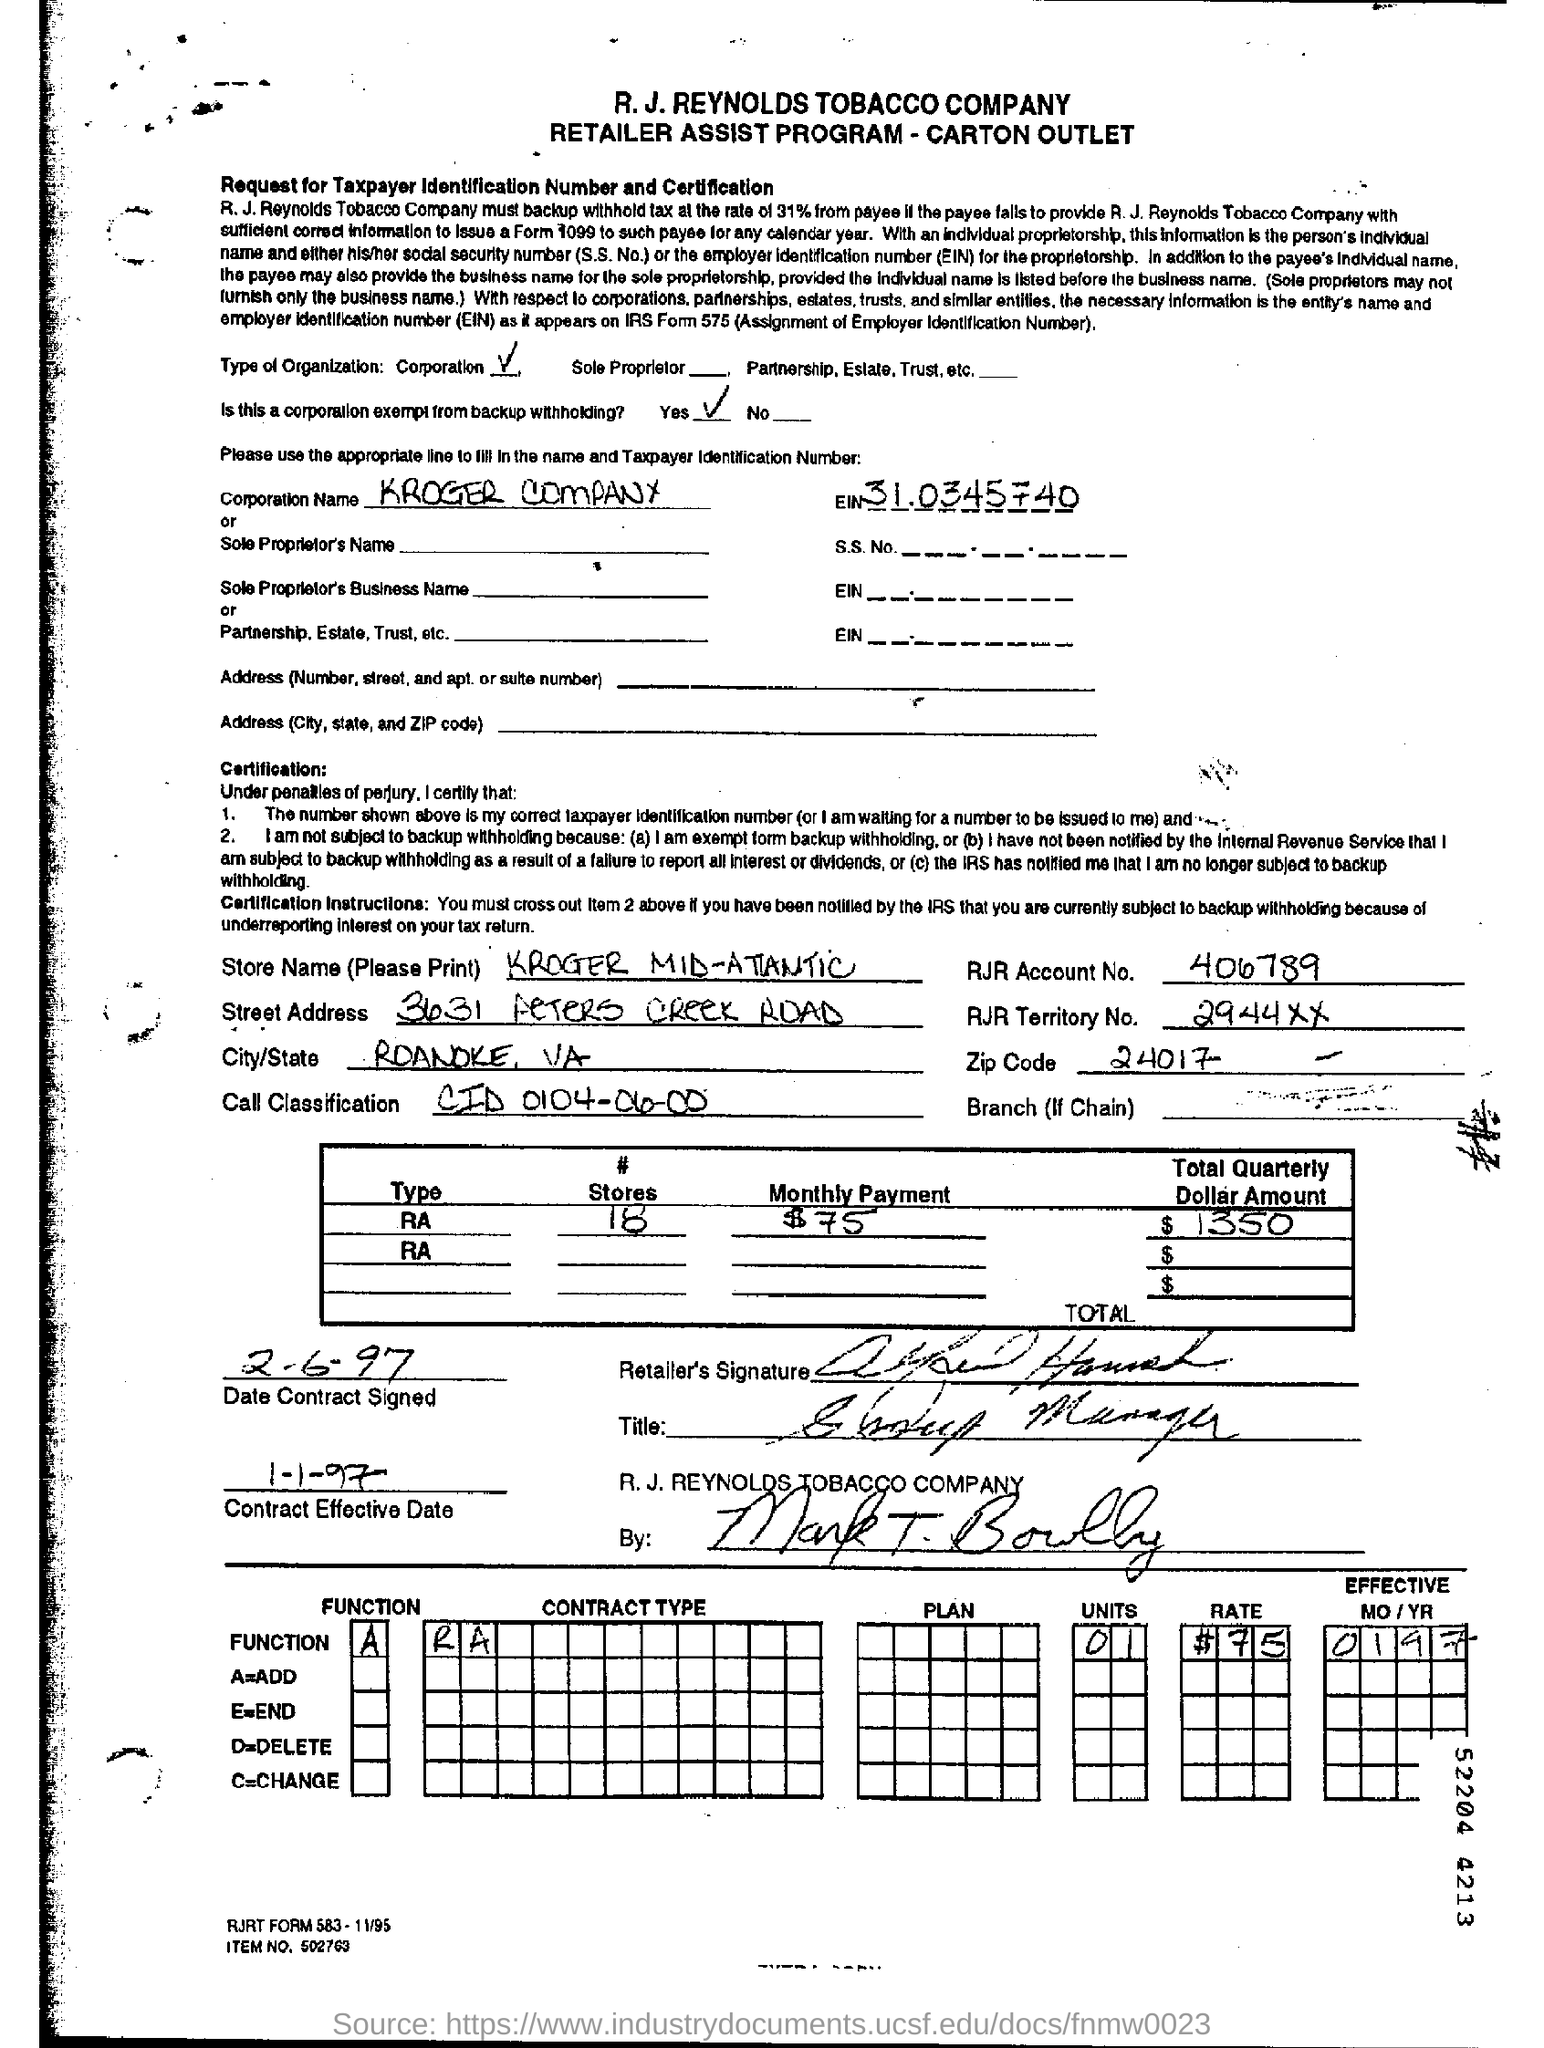Draw attention to some important aspects in this diagram. The zip code mentioned in the document is 24017. The name of the store is KROGER MID-A Kroger Company" is the name of the corporation mentioned. The contract became effective on January 1, 1997. 